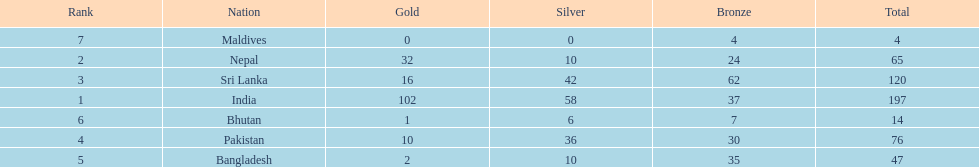Which countries won medals? India, Nepal, Sri Lanka, Pakistan, Bangladesh, Bhutan, Maldives. Which won the most? India. Which won the fewest? Maldives. 